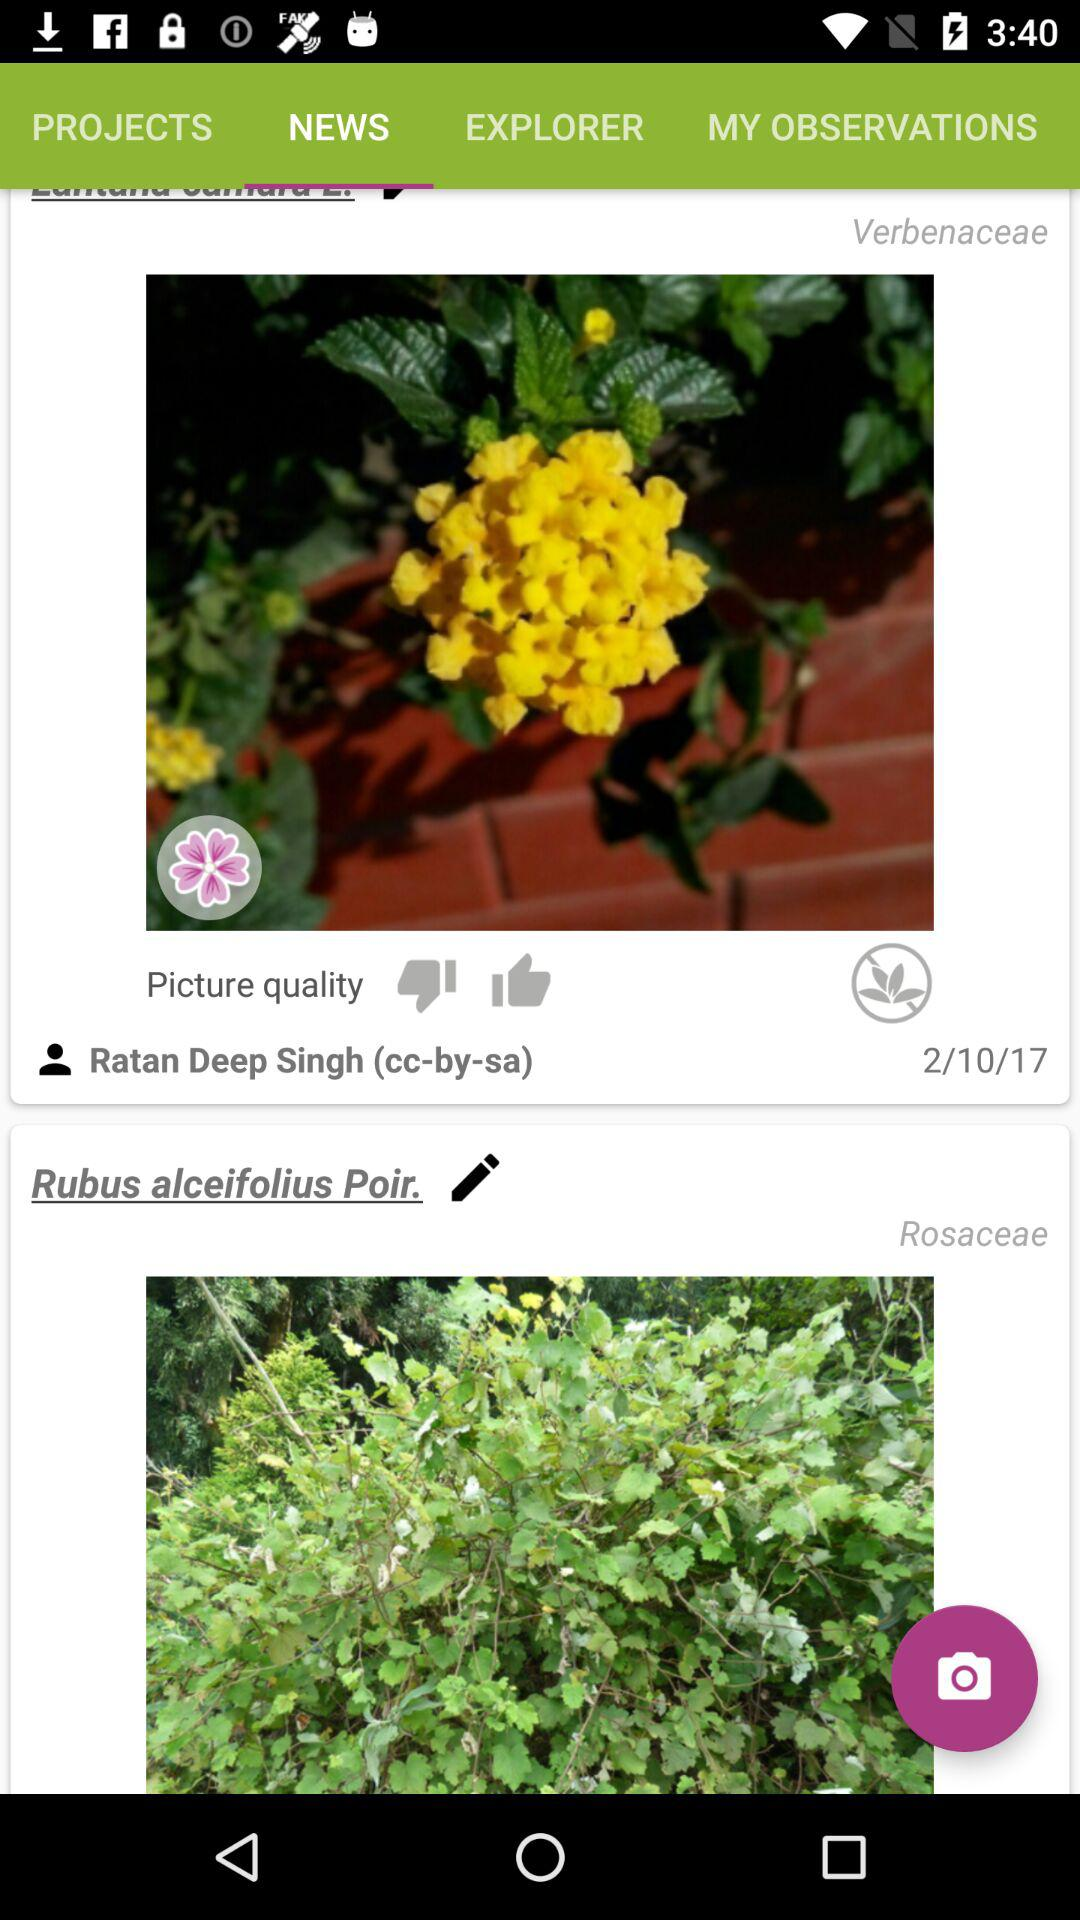In which year was the Verbenaceae photo posted? The photo was posted in 2017. 